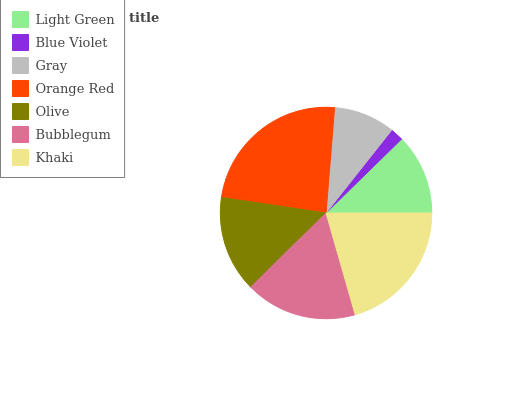Is Blue Violet the minimum?
Answer yes or no. Yes. Is Orange Red the maximum?
Answer yes or no. Yes. Is Gray the minimum?
Answer yes or no. No. Is Gray the maximum?
Answer yes or no. No. Is Gray greater than Blue Violet?
Answer yes or no. Yes. Is Blue Violet less than Gray?
Answer yes or no. Yes. Is Blue Violet greater than Gray?
Answer yes or no. No. Is Gray less than Blue Violet?
Answer yes or no. No. Is Olive the high median?
Answer yes or no. Yes. Is Olive the low median?
Answer yes or no. Yes. Is Orange Red the high median?
Answer yes or no. No. Is Bubblegum the low median?
Answer yes or no. No. 